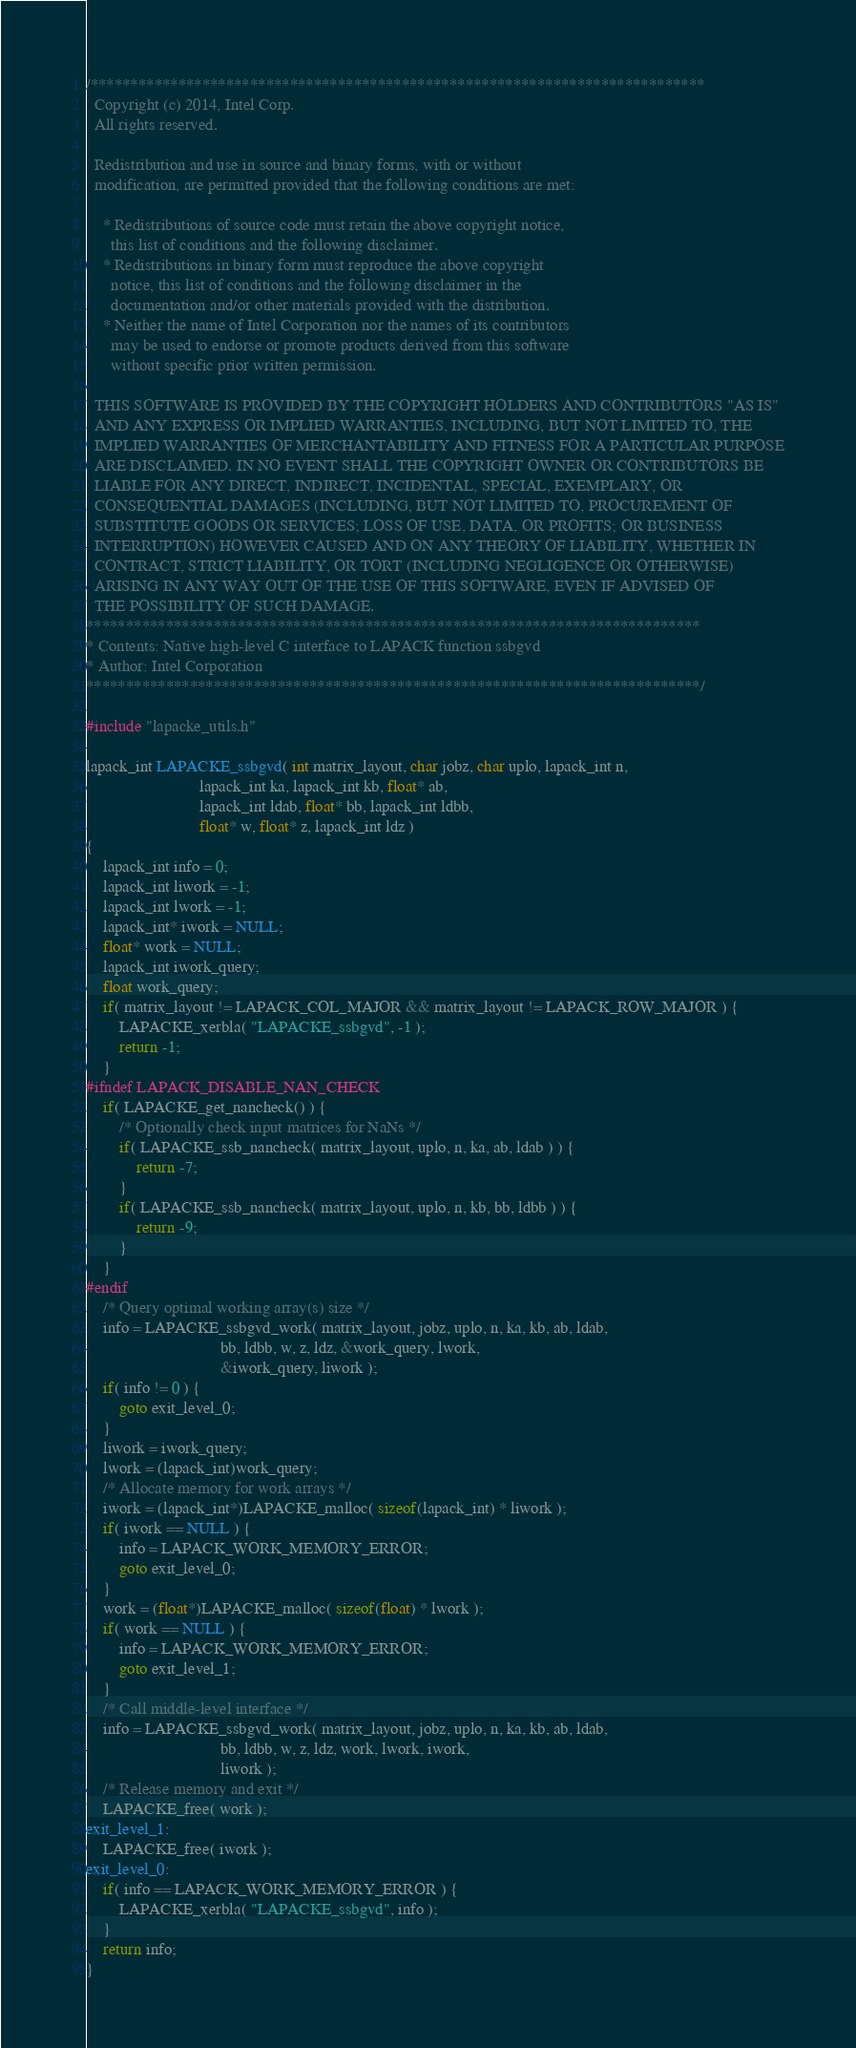Convert code to text. <code><loc_0><loc_0><loc_500><loc_500><_C_>/*****************************************************************************
  Copyright (c) 2014, Intel Corp.
  All rights reserved.

  Redistribution and use in source and binary forms, with or without
  modification, are permitted provided that the following conditions are met:

    * Redistributions of source code must retain the above copyright notice,
      this list of conditions and the following disclaimer.
    * Redistributions in binary form must reproduce the above copyright
      notice, this list of conditions and the following disclaimer in the
      documentation and/or other materials provided with the distribution.
    * Neither the name of Intel Corporation nor the names of its contributors
      may be used to endorse or promote products derived from this software
      without specific prior written permission.

  THIS SOFTWARE IS PROVIDED BY THE COPYRIGHT HOLDERS AND CONTRIBUTORS "AS IS"
  AND ANY EXPRESS OR IMPLIED WARRANTIES, INCLUDING, BUT NOT LIMITED TO, THE
  IMPLIED WARRANTIES OF MERCHANTABILITY AND FITNESS FOR A PARTICULAR PURPOSE
  ARE DISCLAIMED. IN NO EVENT SHALL THE COPYRIGHT OWNER OR CONTRIBUTORS BE
  LIABLE FOR ANY DIRECT, INDIRECT, INCIDENTAL, SPECIAL, EXEMPLARY, OR
  CONSEQUENTIAL DAMAGES (INCLUDING, BUT NOT LIMITED TO, PROCUREMENT OF
  SUBSTITUTE GOODS OR SERVICES; LOSS OF USE, DATA, OR PROFITS; OR BUSINESS
  INTERRUPTION) HOWEVER CAUSED AND ON ANY THEORY OF LIABILITY, WHETHER IN
  CONTRACT, STRICT LIABILITY, OR TORT (INCLUDING NEGLIGENCE OR OTHERWISE)
  ARISING IN ANY WAY OUT OF THE USE OF THIS SOFTWARE, EVEN IF ADVISED OF
  THE POSSIBILITY OF SUCH DAMAGE.
*****************************************************************************
* Contents: Native high-level C interface to LAPACK function ssbgvd
* Author: Intel Corporation
*****************************************************************************/

#include "lapacke_utils.h"

lapack_int LAPACKE_ssbgvd( int matrix_layout, char jobz, char uplo, lapack_int n,
                           lapack_int ka, lapack_int kb, float* ab,
                           lapack_int ldab, float* bb, lapack_int ldbb,
                           float* w, float* z, lapack_int ldz )
{
    lapack_int info = 0;
    lapack_int liwork = -1;
    lapack_int lwork = -1;
    lapack_int* iwork = NULL;
    float* work = NULL;
    lapack_int iwork_query;
    float work_query;
    if( matrix_layout != LAPACK_COL_MAJOR && matrix_layout != LAPACK_ROW_MAJOR ) {
        LAPACKE_xerbla( "LAPACKE_ssbgvd", -1 );
        return -1;
    }
#ifndef LAPACK_DISABLE_NAN_CHECK
    if( LAPACKE_get_nancheck() ) {
        /* Optionally check input matrices for NaNs */
        if( LAPACKE_ssb_nancheck( matrix_layout, uplo, n, ka, ab, ldab ) ) {
            return -7;
        }
        if( LAPACKE_ssb_nancheck( matrix_layout, uplo, n, kb, bb, ldbb ) ) {
            return -9;
        }
    }
#endif
    /* Query optimal working array(s) size */
    info = LAPACKE_ssbgvd_work( matrix_layout, jobz, uplo, n, ka, kb, ab, ldab,
                                bb, ldbb, w, z, ldz, &work_query, lwork,
                                &iwork_query, liwork );
    if( info != 0 ) {
        goto exit_level_0;
    }
    liwork = iwork_query;
    lwork = (lapack_int)work_query;
    /* Allocate memory for work arrays */
    iwork = (lapack_int*)LAPACKE_malloc( sizeof(lapack_int) * liwork );
    if( iwork == NULL ) {
        info = LAPACK_WORK_MEMORY_ERROR;
        goto exit_level_0;
    }
    work = (float*)LAPACKE_malloc( sizeof(float) * lwork );
    if( work == NULL ) {
        info = LAPACK_WORK_MEMORY_ERROR;
        goto exit_level_1;
    }
    /* Call middle-level interface */
    info = LAPACKE_ssbgvd_work( matrix_layout, jobz, uplo, n, ka, kb, ab, ldab,
                                bb, ldbb, w, z, ldz, work, lwork, iwork,
                                liwork );
    /* Release memory and exit */
    LAPACKE_free( work );
exit_level_1:
    LAPACKE_free( iwork );
exit_level_0:
    if( info == LAPACK_WORK_MEMORY_ERROR ) {
        LAPACKE_xerbla( "LAPACKE_ssbgvd", info );
    }
    return info;
}
</code> 